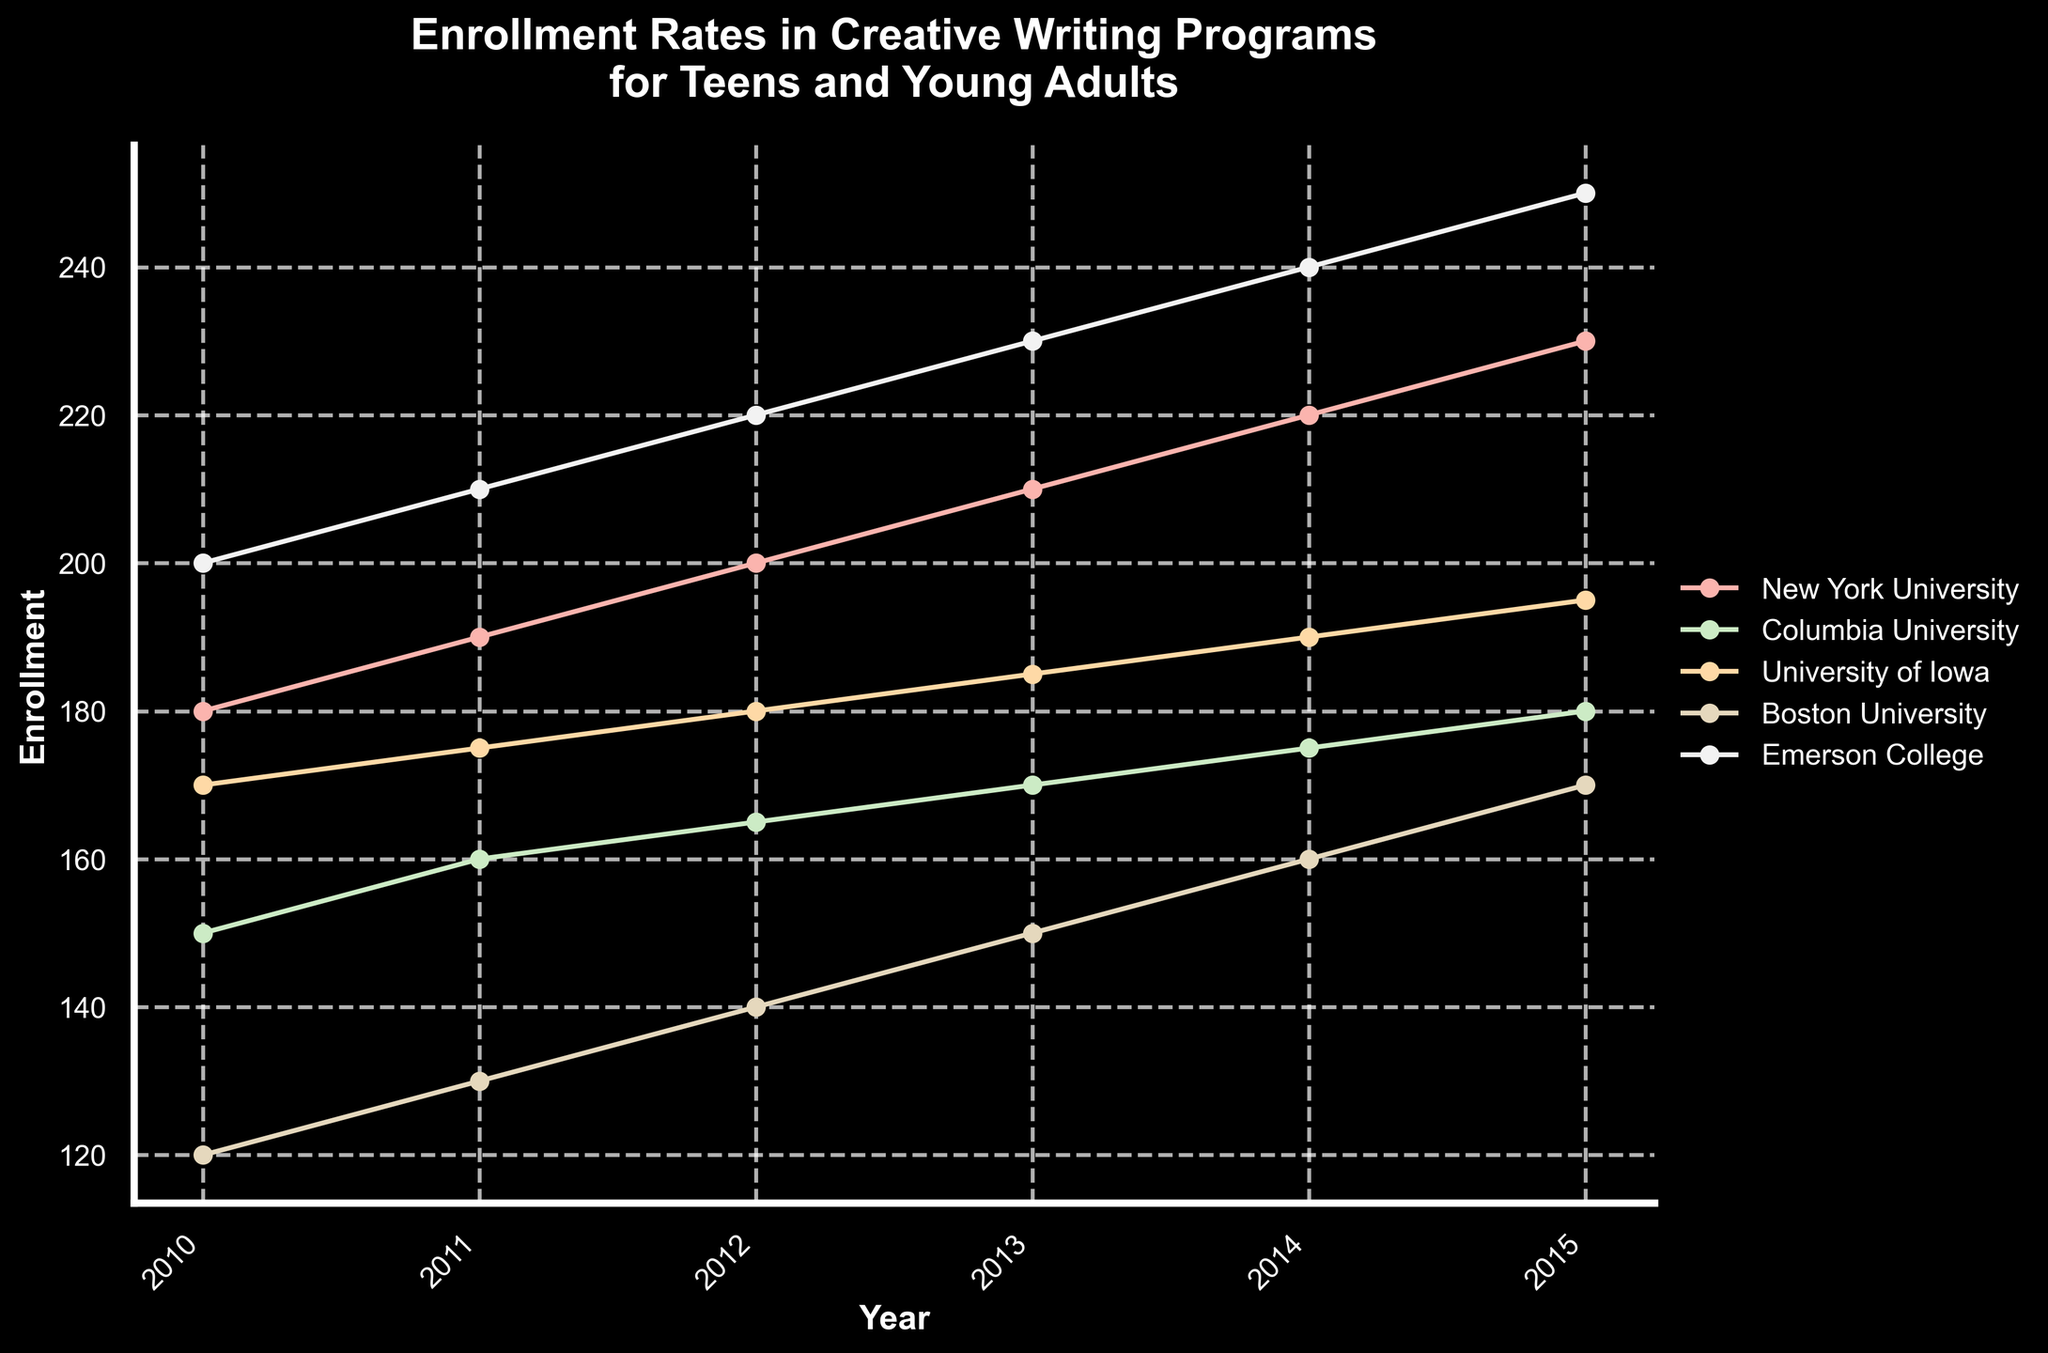What is the title of the plot? The title is located at the top center of the plot and provides an overview of the visual content.
Answer: Enrollment Rates in Creative Writing Programs for Teens and Young Adults Which university had the highest enrollment in 2015? To determine the highest enrollment in 2015, locate the data points for each university at the 2015 mark and compare their values.
Answer: Emerson College What trend can be observed in the enrollment at New York University over the years? Follow the data points connected for New York University from 2010 to 2015 and observe the overall direction of the curve.
Answer: Increasing trend What is the difference in enrollment between Columbia University and University of Iowa in 2014? Identify the enrollment values for both universities in 2014, then subtract the value for University of Iowa from the value for Columbia University.
Answer: -15 Which university showed the most consistent increase over the years? Examine the trend lines for each university, looking for a line that steadily increases without significant drops.
Answer: Emerson College In which year did Boston University have the lowest enrollment? Locate the data points for Boston University and identify the year with the smallest value.
Answer: 2010 How many universities had an enrollment of over 200 in 2014? For each university, check the enrollment point for 2014 and count how many exceed 200.
Answer: 2 Did any university experience a decrease in enrollment from 2013 to 2014? Compare the enrollment values for each university between 2013 and 2014 to see if any shows a decline.
Answer: No 